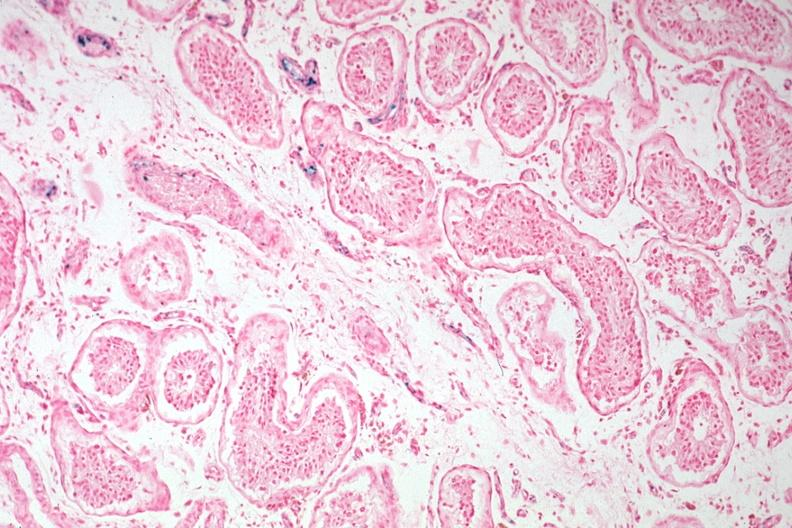s testicle present?
Answer the question using a single word or phrase. Yes 